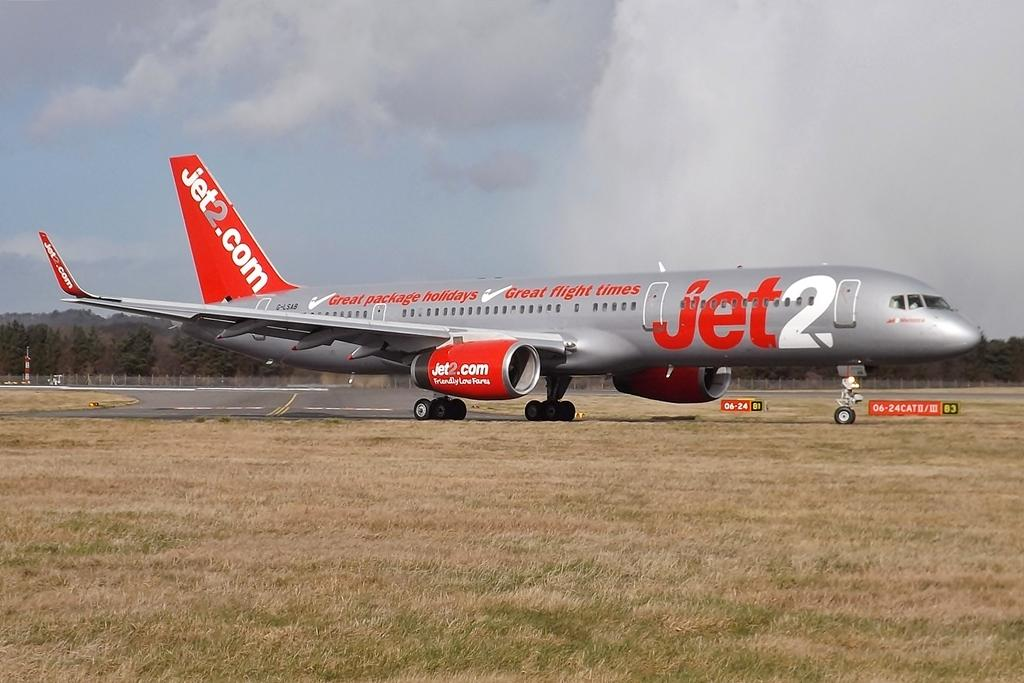Provide a one-sentence caption for the provided image. A red and silver colored Jet2 airplane is on the runway. 